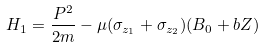<formula> <loc_0><loc_0><loc_500><loc_500>H _ { 1 } = \frac { P ^ { 2 } } { 2 m } - \mu ( \sigma _ { z _ { 1 } } + \sigma _ { z _ { 2 } } ) ( B _ { 0 } + b Z )</formula> 